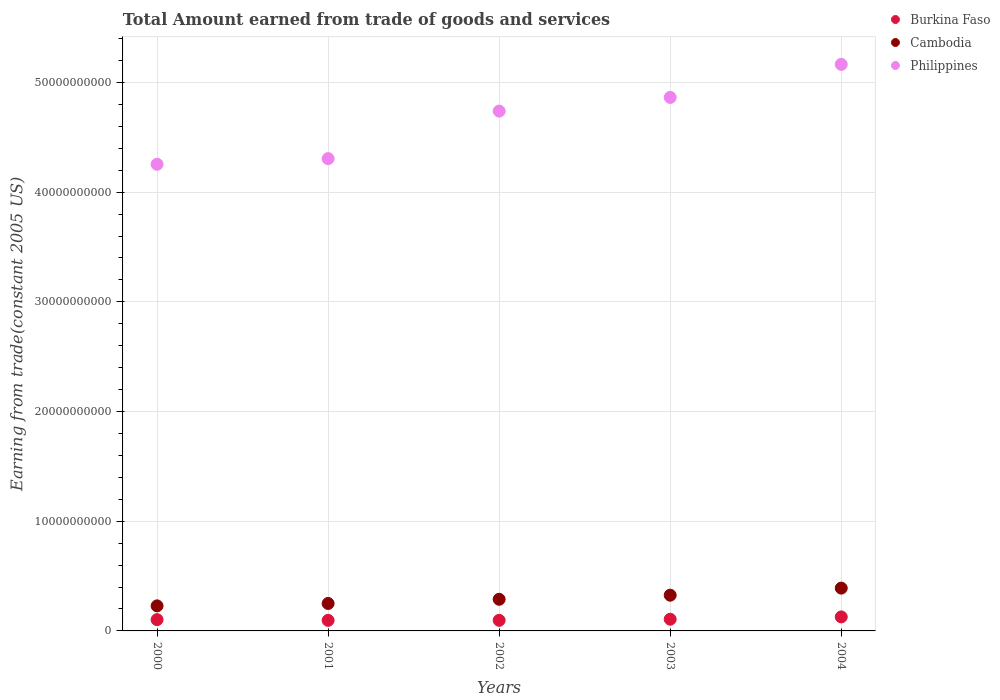How many different coloured dotlines are there?
Offer a very short reply. 3. Is the number of dotlines equal to the number of legend labels?
Give a very brief answer. Yes. What is the total amount earned by trading goods and services in Cambodia in 2004?
Provide a succinct answer. 3.90e+09. Across all years, what is the maximum total amount earned by trading goods and services in Burkina Faso?
Your response must be concise. 1.28e+09. Across all years, what is the minimum total amount earned by trading goods and services in Cambodia?
Ensure brevity in your answer.  2.28e+09. In which year was the total amount earned by trading goods and services in Cambodia maximum?
Give a very brief answer. 2004. What is the total total amount earned by trading goods and services in Burkina Faso in the graph?
Make the answer very short. 5.30e+09. What is the difference between the total amount earned by trading goods and services in Philippines in 2000 and that in 2002?
Provide a succinct answer. -4.85e+09. What is the difference between the total amount earned by trading goods and services in Burkina Faso in 2001 and the total amount earned by trading goods and services in Cambodia in 2000?
Your answer should be very brief. -1.32e+09. What is the average total amount earned by trading goods and services in Burkina Faso per year?
Your answer should be compact. 1.06e+09. In the year 2003, what is the difference between the total amount earned by trading goods and services in Philippines and total amount earned by trading goods and services in Cambodia?
Offer a terse response. 4.54e+1. What is the ratio of the total amount earned by trading goods and services in Cambodia in 2003 to that in 2004?
Offer a terse response. 0.83. What is the difference between the highest and the second highest total amount earned by trading goods and services in Burkina Faso?
Offer a terse response. 2.11e+08. What is the difference between the highest and the lowest total amount earned by trading goods and services in Burkina Faso?
Provide a short and direct response. 3.15e+08. In how many years, is the total amount earned by trading goods and services in Cambodia greater than the average total amount earned by trading goods and services in Cambodia taken over all years?
Keep it short and to the point. 2. Is the sum of the total amount earned by trading goods and services in Cambodia in 2000 and 2002 greater than the maximum total amount earned by trading goods and services in Philippines across all years?
Make the answer very short. No. Does the total amount earned by trading goods and services in Philippines monotonically increase over the years?
Give a very brief answer. Yes. Is the total amount earned by trading goods and services in Cambodia strictly less than the total amount earned by trading goods and services in Philippines over the years?
Give a very brief answer. Yes. How many dotlines are there?
Make the answer very short. 3. How many years are there in the graph?
Offer a very short reply. 5. Does the graph contain any zero values?
Ensure brevity in your answer.  No. Where does the legend appear in the graph?
Ensure brevity in your answer.  Top right. What is the title of the graph?
Offer a terse response. Total Amount earned from trade of goods and services. Does "Timor-Leste" appear as one of the legend labels in the graph?
Give a very brief answer. No. What is the label or title of the X-axis?
Give a very brief answer. Years. What is the label or title of the Y-axis?
Offer a terse response. Earning from trade(constant 2005 US). What is the Earning from trade(constant 2005 US) in Burkina Faso in 2000?
Offer a terse response. 1.03e+09. What is the Earning from trade(constant 2005 US) of Cambodia in 2000?
Give a very brief answer. 2.28e+09. What is the Earning from trade(constant 2005 US) in Philippines in 2000?
Your answer should be very brief. 4.25e+1. What is the Earning from trade(constant 2005 US) in Burkina Faso in 2001?
Offer a terse response. 9.63e+08. What is the Earning from trade(constant 2005 US) of Cambodia in 2001?
Provide a succinct answer. 2.50e+09. What is the Earning from trade(constant 2005 US) in Philippines in 2001?
Provide a short and direct response. 4.31e+1. What is the Earning from trade(constant 2005 US) in Burkina Faso in 2002?
Offer a very short reply. 9.65e+08. What is the Earning from trade(constant 2005 US) of Cambodia in 2002?
Ensure brevity in your answer.  2.88e+09. What is the Earning from trade(constant 2005 US) in Philippines in 2002?
Your answer should be very brief. 4.74e+1. What is the Earning from trade(constant 2005 US) of Burkina Faso in 2003?
Offer a terse response. 1.07e+09. What is the Earning from trade(constant 2005 US) of Cambodia in 2003?
Your answer should be compact. 3.26e+09. What is the Earning from trade(constant 2005 US) of Philippines in 2003?
Make the answer very short. 4.86e+1. What is the Earning from trade(constant 2005 US) in Burkina Faso in 2004?
Provide a short and direct response. 1.28e+09. What is the Earning from trade(constant 2005 US) of Cambodia in 2004?
Your answer should be compact. 3.90e+09. What is the Earning from trade(constant 2005 US) of Philippines in 2004?
Offer a very short reply. 5.16e+1. Across all years, what is the maximum Earning from trade(constant 2005 US) in Burkina Faso?
Your answer should be very brief. 1.28e+09. Across all years, what is the maximum Earning from trade(constant 2005 US) of Cambodia?
Your answer should be very brief. 3.90e+09. Across all years, what is the maximum Earning from trade(constant 2005 US) of Philippines?
Your answer should be compact. 5.16e+1. Across all years, what is the minimum Earning from trade(constant 2005 US) of Burkina Faso?
Ensure brevity in your answer.  9.63e+08. Across all years, what is the minimum Earning from trade(constant 2005 US) of Cambodia?
Keep it short and to the point. 2.28e+09. Across all years, what is the minimum Earning from trade(constant 2005 US) of Philippines?
Give a very brief answer. 4.25e+1. What is the total Earning from trade(constant 2005 US) in Burkina Faso in the graph?
Make the answer very short. 5.30e+09. What is the total Earning from trade(constant 2005 US) of Cambodia in the graph?
Provide a short and direct response. 1.48e+1. What is the total Earning from trade(constant 2005 US) of Philippines in the graph?
Your response must be concise. 2.33e+11. What is the difference between the Earning from trade(constant 2005 US) of Burkina Faso in 2000 and that in 2001?
Keep it short and to the point. 6.56e+07. What is the difference between the Earning from trade(constant 2005 US) of Cambodia in 2000 and that in 2001?
Make the answer very short. -2.18e+08. What is the difference between the Earning from trade(constant 2005 US) of Philippines in 2000 and that in 2001?
Ensure brevity in your answer.  -5.15e+08. What is the difference between the Earning from trade(constant 2005 US) in Burkina Faso in 2000 and that in 2002?
Ensure brevity in your answer.  6.34e+07. What is the difference between the Earning from trade(constant 2005 US) in Cambodia in 2000 and that in 2002?
Ensure brevity in your answer.  -6.00e+08. What is the difference between the Earning from trade(constant 2005 US) in Philippines in 2000 and that in 2002?
Keep it short and to the point. -4.85e+09. What is the difference between the Earning from trade(constant 2005 US) of Burkina Faso in 2000 and that in 2003?
Make the answer very short. -3.80e+07. What is the difference between the Earning from trade(constant 2005 US) of Cambodia in 2000 and that in 2003?
Provide a succinct answer. -9.73e+08. What is the difference between the Earning from trade(constant 2005 US) in Philippines in 2000 and that in 2003?
Your answer should be very brief. -6.09e+09. What is the difference between the Earning from trade(constant 2005 US) of Burkina Faso in 2000 and that in 2004?
Make the answer very short. -2.49e+08. What is the difference between the Earning from trade(constant 2005 US) of Cambodia in 2000 and that in 2004?
Keep it short and to the point. -1.62e+09. What is the difference between the Earning from trade(constant 2005 US) in Philippines in 2000 and that in 2004?
Offer a very short reply. -9.11e+09. What is the difference between the Earning from trade(constant 2005 US) in Burkina Faso in 2001 and that in 2002?
Your answer should be very brief. -2.19e+06. What is the difference between the Earning from trade(constant 2005 US) of Cambodia in 2001 and that in 2002?
Give a very brief answer. -3.82e+08. What is the difference between the Earning from trade(constant 2005 US) of Philippines in 2001 and that in 2002?
Your response must be concise. -4.33e+09. What is the difference between the Earning from trade(constant 2005 US) of Burkina Faso in 2001 and that in 2003?
Your response must be concise. -1.04e+08. What is the difference between the Earning from trade(constant 2005 US) in Cambodia in 2001 and that in 2003?
Provide a short and direct response. -7.55e+08. What is the difference between the Earning from trade(constant 2005 US) in Philippines in 2001 and that in 2003?
Make the answer very short. -5.58e+09. What is the difference between the Earning from trade(constant 2005 US) in Burkina Faso in 2001 and that in 2004?
Your answer should be compact. -3.15e+08. What is the difference between the Earning from trade(constant 2005 US) in Cambodia in 2001 and that in 2004?
Keep it short and to the point. -1.40e+09. What is the difference between the Earning from trade(constant 2005 US) of Philippines in 2001 and that in 2004?
Offer a terse response. -8.59e+09. What is the difference between the Earning from trade(constant 2005 US) of Burkina Faso in 2002 and that in 2003?
Provide a short and direct response. -1.01e+08. What is the difference between the Earning from trade(constant 2005 US) of Cambodia in 2002 and that in 2003?
Ensure brevity in your answer.  -3.73e+08. What is the difference between the Earning from trade(constant 2005 US) in Philippines in 2002 and that in 2003?
Offer a very short reply. -1.25e+09. What is the difference between the Earning from trade(constant 2005 US) in Burkina Faso in 2002 and that in 2004?
Provide a short and direct response. -3.13e+08. What is the difference between the Earning from trade(constant 2005 US) of Cambodia in 2002 and that in 2004?
Offer a terse response. -1.02e+09. What is the difference between the Earning from trade(constant 2005 US) of Philippines in 2002 and that in 2004?
Offer a very short reply. -4.26e+09. What is the difference between the Earning from trade(constant 2005 US) in Burkina Faso in 2003 and that in 2004?
Ensure brevity in your answer.  -2.11e+08. What is the difference between the Earning from trade(constant 2005 US) in Cambodia in 2003 and that in 2004?
Provide a short and direct response. -6.46e+08. What is the difference between the Earning from trade(constant 2005 US) of Philippines in 2003 and that in 2004?
Your answer should be compact. -3.01e+09. What is the difference between the Earning from trade(constant 2005 US) in Burkina Faso in 2000 and the Earning from trade(constant 2005 US) in Cambodia in 2001?
Provide a short and direct response. -1.47e+09. What is the difference between the Earning from trade(constant 2005 US) of Burkina Faso in 2000 and the Earning from trade(constant 2005 US) of Philippines in 2001?
Keep it short and to the point. -4.20e+1. What is the difference between the Earning from trade(constant 2005 US) of Cambodia in 2000 and the Earning from trade(constant 2005 US) of Philippines in 2001?
Ensure brevity in your answer.  -4.08e+1. What is the difference between the Earning from trade(constant 2005 US) of Burkina Faso in 2000 and the Earning from trade(constant 2005 US) of Cambodia in 2002?
Offer a very short reply. -1.85e+09. What is the difference between the Earning from trade(constant 2005 US) in Burkina Faso in 2000 and the Earning from trade(constant 2005 US) in Philippines in 2002?
Provide a short and direct response. -4.64e+1. What is the difference between the Earning from trade(constant 2005 US) of Cambodia in 2000 and the Earning from trade(constant 2005 US) of Philippines in 2002?
Offer a very short reply. -4.51e+1. What is the difference between the Earning from trade(constant 2005 US) of Burkina Faso in 2000 and the Earning from trade(constant 2005 US) of Cambodia in 2003?
Your response must be concise. -2.23e+09. What is the difference between the Earning from trade(constant 2005 US) of Burkina Faso in 2000 and the Earning from trade(constant 2005 US) of Philippines in 2003?
Your answer should be compact. -4.76e+1. What is the difference between the Earning from trade(constant 2005 US) of Cambodia in 2000 and the Earning from trade(constant 2005 US) of Philippines in 2003?
Give a very brief answer. -4.64e+1. What is the difference between the Earning from trade(constant 2005 US) in Burkina Faso in 2000 and the Earning from trade(constant 2005 US) in Cambodia in 2004?
Ensure brevity in your answer.  -2.87e+09. What is the difference between the Earning from trade(constant 2005 US) of Burkina Faso in 2000 and the Earning from trade(constant 2005 US) of Philippines in 2004?
Your answer should be compact. -5.06e+1. What is the difference between the Earning from trade(constant 2005 US) in Cambodia in 2000 and the Earning from trade(constant 2005 US) in Philippines in 2004?
Provide a short and direct response. -4.94e+1. What is the difference between the Earning from trade(constant 2005 US) of Burkina Faso in 2001 and the Earning from trade(constant 2005 US) of Cambodia in 2002?
Offer a very short reply. -1.92e+09. What is the difference between the Earning from trade(constant 2005 US) of Burkina Faso in 2001 and the Earning from trade(constant 2005 US) of Philippines in 2002?
Keep it short and to the point. -4.64e+1. What is the difference between the Earning from trade(constant 2005 US) of Cambodia in 2001 and the Earning from trade(constant 2005 US) of Philippines in 2002?
Provide a short and direct response. -4.49e+1. What is the difference between the Earning from trade(constant 2005 US) of Burkina Faso in 2001 and the Earning from trade(constant 2005 US) of Cambodia in 2003?
Keep it short and to the point. -2.29e+09. What is the difference between the Earning from trade(constant 2005 US) of Burkina Faso in 2001 and the Earning from trade(constant 2005 US) of Philippines in 2003?
Your answer should be compact. -4.77e+1. What is the difference between the Earning from trade(constant 2005 US) in Cambodia in 2001 and the Earning from trade(constant 2005 US) in Philippines in 2003?
Make the answer very short. -4.61e+1. What is the difference between the Earning from trade(constant 2005 US) in Burkina Faso in 2001 and the Earning from trade(constant 2005 US) in Cambodia in 2004?
Your answer should be very brief. -2.94e+09. What is the difference between the Earning from trade(constant 2005 US) in Burkina Faso in 2001 and the Earning from trade(constant 2005 US) in Philippines in 2004?
Your answer should be compact. -5.07e+1. What is the difference between the Earning from trade(constant 2005 US) of Cambodia in 2001 and the Earning from trade(constant 2005 US) of Philippines in 2004?
Keep it short and to the point. -4.91e+1. What is the difference between the Earning from trade(constant 2005 US) of Burkina Faso in 2002 and the Earning from trade(constant 2005 US) of Cambodia in 2003?
Make the answer very short. -2.29e+09. What is the difference between the Earning from trade(constant 2005 US) in Burkina Faso in 2002 and the Earning from trade(constant 2005 US) in Philippines in 2003?
Keep it short and to the point. -4.77e+1. What is the difference between the Earning from trade(constant 2005 US) of Cambodia in 2002 and the Earning from trade(constant 2005 US) of Philippines in 2003?
Make the answer very short. -4.58e+1. What is the difference between the Earning from trade(constant 2005 US) of Burkina Faso in 2002 and the Earning from trade(constant 2005 US) of Cambodia in 2004?
Ensure brevity in your answer.  -2.94e+09. What is the difference between the Earning from trade(constant 2005 US) of Burkina Faso in 2002 and the Earning from trade(constant 2005 US) of Philippines in 2004?
Give a very brief answer. -5.07e+1. What is the difference between the Earning from trade(constant 2005 US) in Cambodia in 2002 and the Earning from trade(constant 2005 US) in Philippines in 2004?
Your answer should be compact. -4.88e+1. What is the difference between the Earning from trade(constant 2005 US) in Burkina Faso in 2003 and the Earning from trade(constant 2005 US) in Cambodia in 2004?
Provide a short and direct response. -2.84e+09. What is the difference between the Earning from trade(constant 2005 US) of Burkina Faso in 2003 and the Earning from trade(constant 2005 US) of Philippines in 2004?
Your answer should be compact. -5.06e+1. What is the difference between the Earning from trade(constant 2005 US) in Cambodia in 2003 and the Earning from trade(constant 2005 US) in Philippines in 2004?
Give a very brief answer. -4.84e+1. What is the average Earning from trade(constant 2005 US) in Burkina Faso per year?
Make the answer very short. 1.06e+09. What is the average Earning from trade(constant 2005 US) in Cambodia per year?
Your answer should be compact. 2.97e+09. What is the average Earning from trade(constant 2005 US) of Philippines per year?
Your answer should be compact. 4.67e+1. In the year 2000, what is the difference between the Earning from trade(constant 2005 US) of Burkina Faso and Earning from trade(constant 2005 US) of Cambodia?
Give a very brief answer. -1.26e+09. In the year 2000, what is the difference between the Earning from trade(constant 2005 US) of Burkina Faso and Earning from trade(constant 2005 US) of Philippines?
Offer a terse response. -4.15e+1. In the year 2000, what is the difference between the Earning from trade(constant 2005 US) in Cambodia and Earning from trade(constant 2005 US) in Philippines?
Offer a terse response. -4.03e+1. In the year 2001, what is the difference between the Earning from trade(constant 2005 US) of Burkina Faso and Earning from trade(constant 2005 US) of Cambodia?
Keep it short and to the point. -1.54e+09. In the year 2001, what is the difference between the Earning from trade(constant 2005 US) of Burkina Faso and Earning from trade(constant 2005 US) of Philippines?
Your answer should be compact. -4.21e+1. In the year 2001, what is the difference between the Earning from trade(constant 2005 US) in Cambodia and Earning from trade(constant 2005 US) in Philippines?
Make the answer very short. -4.06e+1. In the year 2002, what is the difference between the Earning from trade(constant 2005 US) of Burkina Faso and Earning from trade(constant 2005 US) of Cambodia?
Provide a short and direct response. -1.92e+09. In the year 2002, what is the difference between the Earning from trade(constant 2005 US) in Burkina Faso and Earning from trade(constant 2005 US) in Philippines?
Provide a succinct answer. -4.64e+1. In the year 2002, what is the difference between the Earning from trade(constant 2005 US) in Cambodia and Earning from trade(constant 2005 US) in Philippines?
Offer a very short reply. -4.45e+1. In the year 2003, what is the difference between the Earning from trade(constant 2005 US) of Burkina Faso and Earning from trade(constant 2005 US) of Cambodia?
Make the answer very short. -2.19e+09. In the year 2003, what is the difference between the Earning from trade(constant 2005 US) in Burkina Faso and Earning from trade(constant 2005 US) in Philippines?
Offer a terse response. -4.76e+1. In the year 2003, what is the difference between the Earning from trade(constant 2005 US) in Cambodia and Earning from trade(constant 2005 US) in Philippines?
Keep it short and to the point. -4.54e+1. In the year 2004, what is the difference between the Earning from trade(constant 2005 US) in Burkina Faso and Earning from trade(constant 2005 US) in Cambodia?
Your response must be concise. -2.62e+09. In the year 2004, what is the difference between the Earning from trade(constant 2005 US) in Burkina Faso and Earning from trade(constant 2005 US) in Philippines?
Provide a short and direct response. -5.04e+1. In the year 2004, what is the difference between the Earning from trade(constant 2005 US) of Cambodia and Earning from trade(constant 2005 US) of Philippines?
Your response must be concise. -4.77e+1. What is the ratio of the Earning from trade(constant 2005 US) of Burkina Faso in 2000 to that in 2001?
Your response must be concise. 1.07. What is the ratio of the Earning from trade(constant 2005 US) of Cambodia in 2000 to that in 2001?
Your response must be concise. 0.91. What is the ratio of the Earning from trade(constant 2005 US) of Burkina Faso in 2000 to that in 2002?
Provide a short and direct response. 1.07. What is the ratio of the Earning from trade(constant 2005 US) of Cambodia in 2000 to that in 2002?
Your response must be concise. 0.79. What is the ratio of the Earning from trade(constant 2005 US) of Philippines in 2000 to that in 2002?
Offer a very short reply. 0.9. What is the ratio of the Earning from trade(constant 2005 US) of Burkina Faso in 2000 to that in 2003?
Your response must be concise. 0.96. What is the ratio of the Earning from trade(constant 2005 US) in Cambodia in 2000 to that in 2003?
Your answer should be very brief. 0.7. What is the ratio of the Earning from trade(constant 2005 US) in Philippines in 2000 to that in 2003?
Your answer should be compact. 0.87. What is the ratio of the Earning from trade(constant 2005 US) in Burkina Faso in 2000 to that in 2004?
Keep it short and to the point. 0.8. What is the ratio of the Earning from trade(constant 2005 US) in Cambodia in 2000 to that in 2004?
Your response must be concise. 0.59. What is the ratio of the Earning from trade(constant 2005 US) of Philippines in 2000 to that in 2004?
Provide a short and direct response. 0.82. What is the ratio of the Earning from trade(constant 2005 US) in Burkina Faso in 2001 to that in 2002?
Provide a short and direct response. 1. What is the ratio of the Earning from trade(constant 2005 US) in Cambodia in 2001 to that in 2002?
Your answer should be compact. 0.87. What is the ratio of the Earning from trade(constant 2005 US) in Philippines in 2001 to that in 2002?
Your response must be concise. 0.91. What is the ratio of the Earning from trade(constant 2005 US) in Burkina Faso in 2001 to that in 2003?
Provide a short and direct response. 0.9. What is the ratio of the Earning from trade(constant 2005 US) of Cambodia in 2001 to that in 2003?
Your answer should be very brief. 0.77. What is the ratio of the Earning from trade(constant 2005 US) of Philippines in 2001 to that in 2003?
Keep it short and to the point. 0.89. What is the ratio of the Earning from trade(constant 2005 US) in Burkina Faso in 2001 to that in 2004?
Give a very brief answer. 0.75. What is the ratio of the Earning from trade(constant 2005 US) in Cambodia in 2001 to that in 2004?
Your answer should be compact. 0.64. What is the ratio of the Earning from trade(constant 2005 US) in Philippines in 2001 to that in 2004?
Provide a short and direct response. 0.83. What is the ratio of the Earning from trade(constant 2005 US) of Burkina Faso in 2002 to that in 2003?
Offer a very short reply. 0.91. What is the ratio of the Earning from trade(constant 2005 US) of Cambodia in 2002 to that in 2003?
Offer a very short reply. 0.89. What is the ratio of the Earning from trade(constant 2005 US) in Philippines in 2002 to that in 2003?
Your answer should be compact. 0.97. What is the ratio of the Earning from trade(constant 2005 US) of Burkina Faso in 2002 to that in 2004?
Your answer should be very brief. 0.76. What is the ratio of the Earning from trade(constant 2005 US) of Cambodia in 2002 to that in 2004?
Your response must be concise. 0.74. What is the ratio of the Earning from trade(constant 2005 US) of Philippines in 2002 to that in 2004?
Provide a succinct answer. 0.92. What is the ratio of the Earning from trade(constant 2005 US) in Burkina Faso in 2003 to that in 2004?
Your answer should be compact. 0.83. What is the ratio of the Earning from trade(constant 2005 US) in Cambodia in 2003 to that in 2004?
Provide a short and direct response. 0.83. What is the ratio of the Earning from trade(constant 2005 US) of Philippines in 2003 to that in 2004?
Provide a succinct answer. 0.94. What is the difference between the highest and the second highest Earning from trade(constant 2005 US) in Burkina Faso?
Provide a short and direct response. 2.11e+08. What is the difference between the highest and the second highest Earning from trade(constant 2005 US) in Cambodia?
Ensure brevity in your answer.  6.46e+08. What is the difference between the highest and the second highest Earning from trade(constant 2005 US) of Philippines?
Ensure brevity in your answer.  3.01e+09. What is the difference between the highest and the lowest Earning from trade(constant 2005 US) in Burkina Faso?
Your answer should be compact. 3.15e+08. What is the difference between the highest and the lowest Earning from trade(constant 2005 US) in Cambodia?
Your response must be concise. 1.62e+09. What is the difference between the highest and the lowest Earning from trade(constant 2005 US) of Philippines?
Make the answer very short. 9.11e+09. 